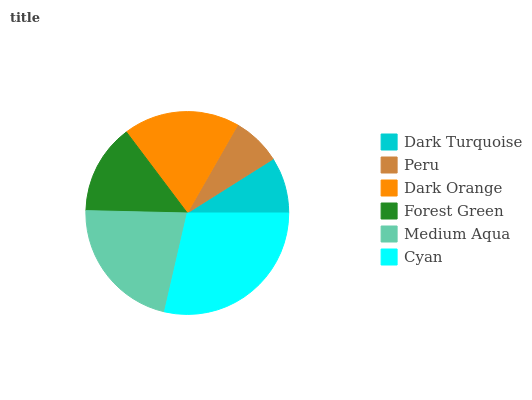Is Peru the minimum?
Answer yes or no. Yes. Is Cyan the maximum?
Answer yes or no. Yes. Is Dark Orange the minimum?
Answer yes or no. No. Is Dark Orange the maximum?
Answer yes or no. No. Is Dark Orange greater than Peru?
Answer yes or no. Yes. Is Peru less than Dark Orange?
Answer yes or no. Yes. Is Peru greater than Dark Orange?
Answer yes or no. No. Is Dark Orange less than Peru?
Answer yes or no. No. Is Dark Orange the high median?
Answer yes or no. Yes. Is Forest Green the low median?
Answer yes or no. Yes. Is Dark Turquoise the high median?
Answer yes or no. No. Is Medium Aqua the low median?
Answer yes or no. No. 